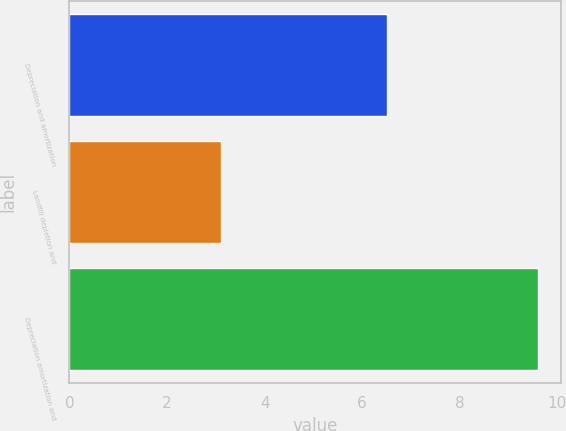Convert chart to OTSL. <chart><loc_0><loc_0><loc_500><loc_500><bar_chart><fcel>Depreciation and amortization<fcel>Landfill depletion and<fcel>Depreciation amortization and<nl><fcel>6.5<fcel>3.1<fcel>9.6<nl></chart> 